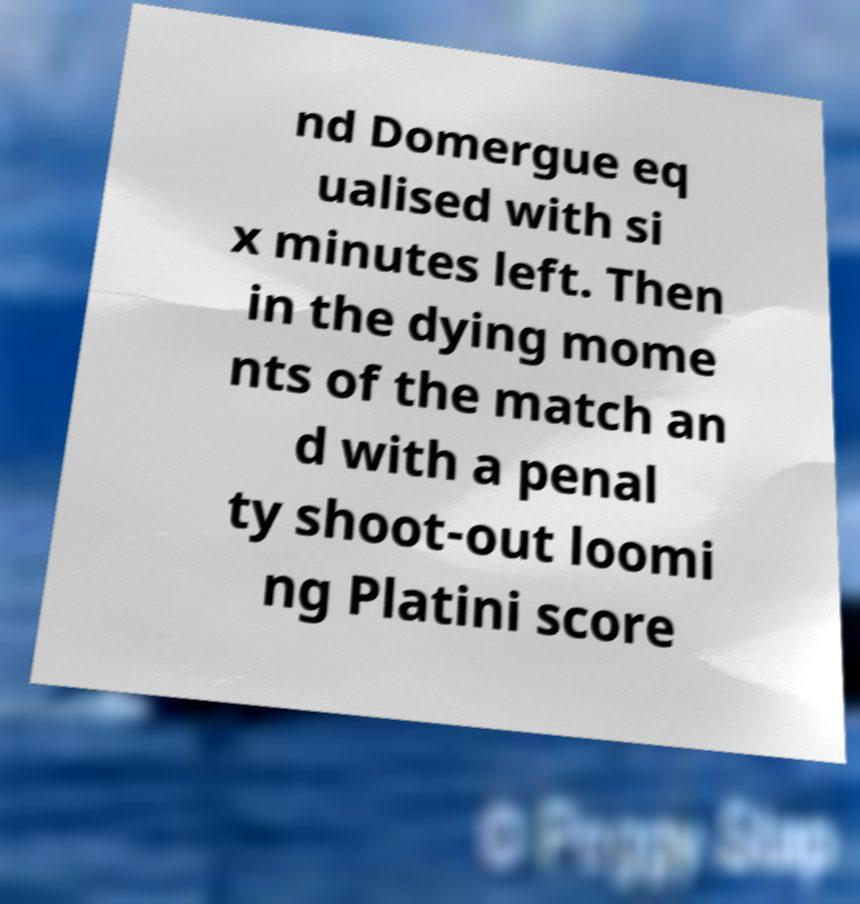Could you assist in decoding the text presented in this image and type it out clearly? nd Domergue eq ualised with si x minutes left. Then in the dying mome nts of the match an d with a penal ty shoot-out loomi ng Platini score 